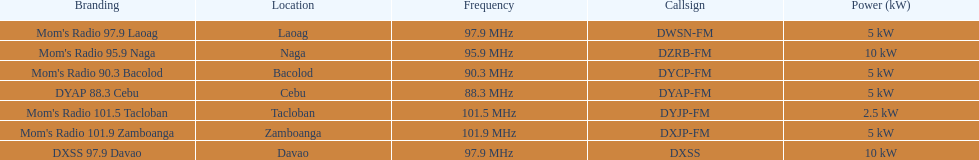What is the sole radio station with a frequency under 90 mhz? DYAP 88.3 Cebu. 